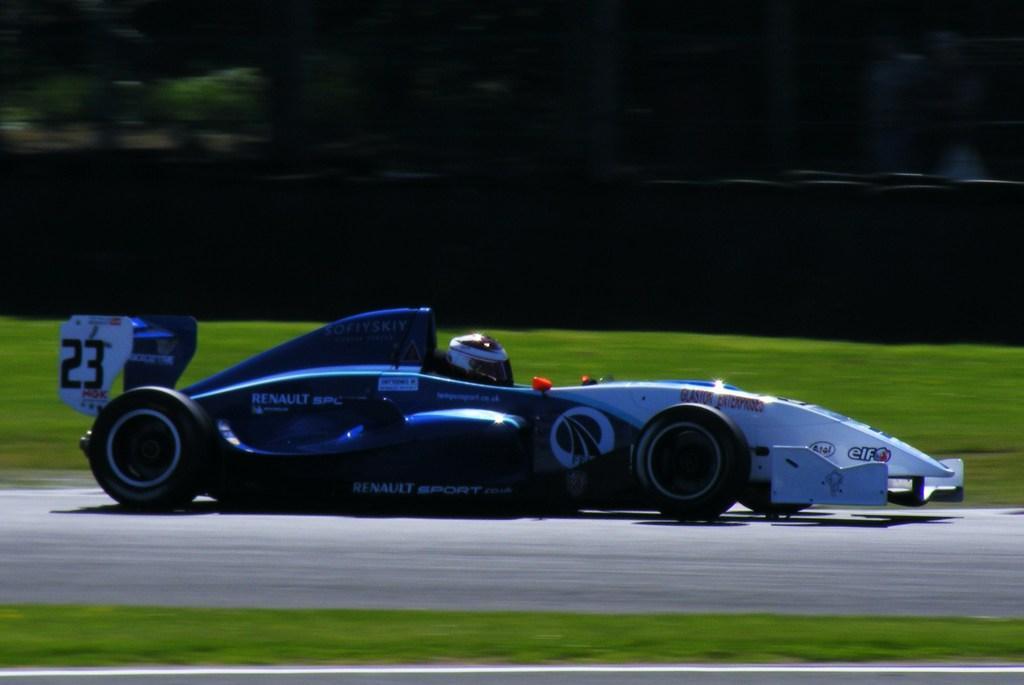Describe this image in one or two sentences. In this picture we can see car on the road and we can see grass and helmet. In the background of the image it is blurry. 